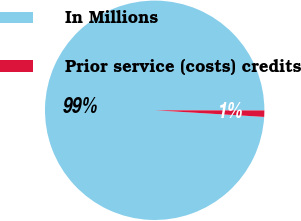Convert chart to OTSL. <chart><loc_0><loc_0><loc_500><loc_500><pie_chart><fcel>In Millions<fcel>Prior service (costs) credits<nl><fcel>99.06%<fcel>0.94%<nl></chart> 